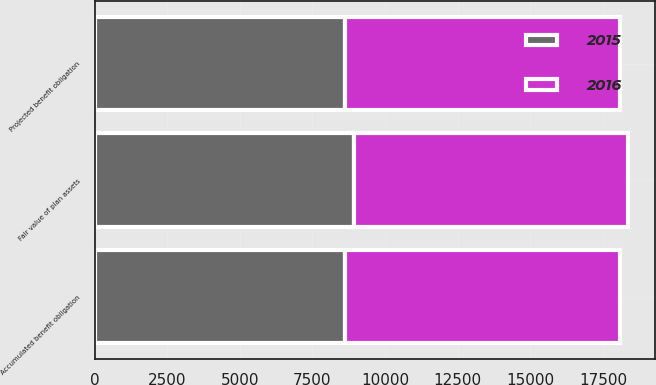<chart> <loc_0><loc_0><loc_500><loc_500><stacked_bar_chart><ecel><fcel>Projected benefit obligation<fcel>Accumulated benefit obligation<fcel>Fair value of plan assets<nl><fcel>2016<fcel>9463<fcel>9457<fcel>9428<nl><fcel>2015<fcel>8635<fcel>8624<fcel>8936<nl></chart> 